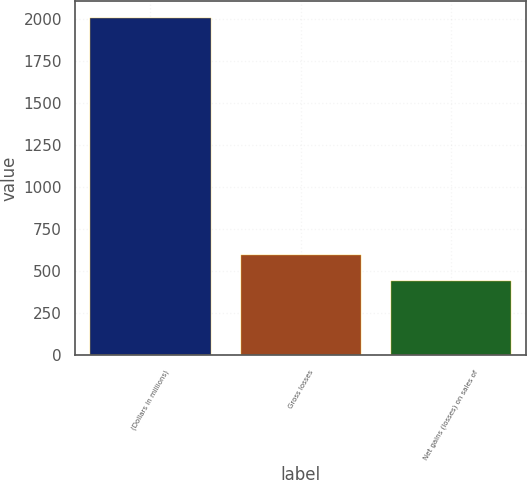Convert chart to OTSL. <chart><loc_0><loc_0><loc_500><loc_500><bar_chart><fcel>(Dollars in millions)<fcel>Gross losses<fcel>Net gains (losses) on sales of<nl><fcel>2006<fcel>599.3<fcel>443<nl></chart> 